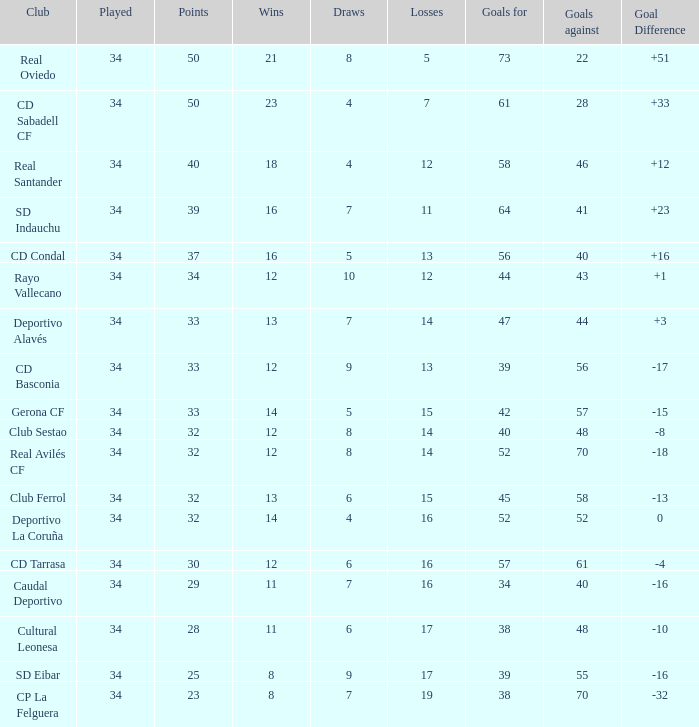Which Losses have a Goal Difference of -16, and less than 8 wins? None. 